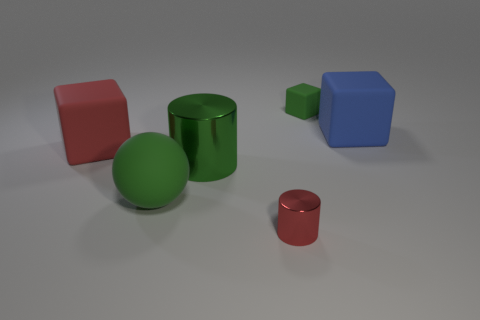Do the objects serve any functional purpose, or are they merely for display? The image seems to be a computer-generated 3D rendering designed to showcase various geometrical shapes and surface materials. As such, they do not serve any practical function in their current context and are solely for visual representation or artistic display. 